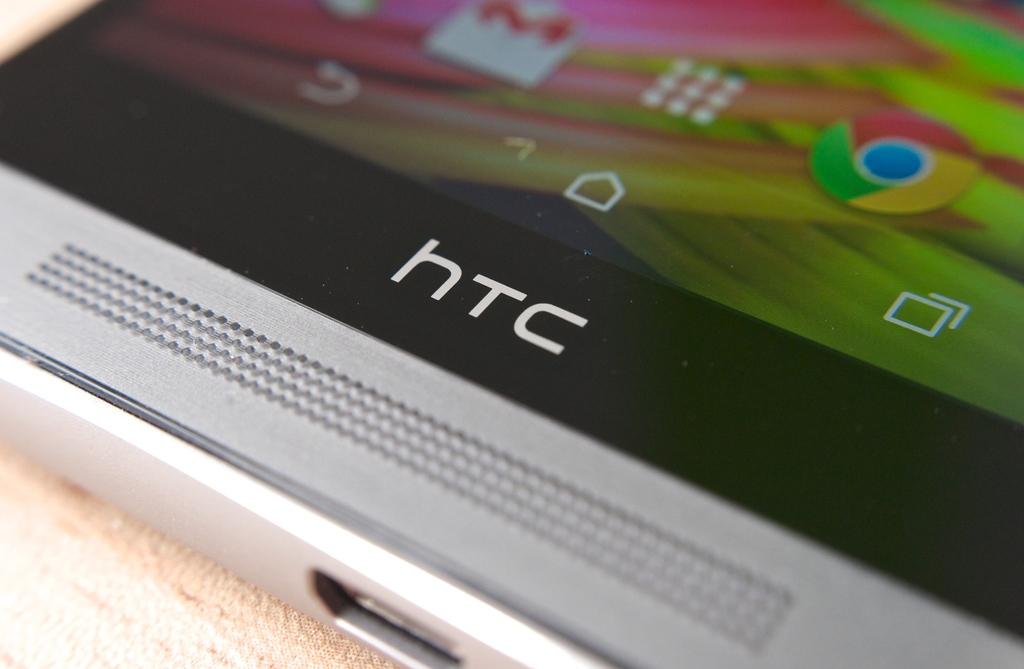Who is the compay of the phone?
Offer a very short reply. Htc. 